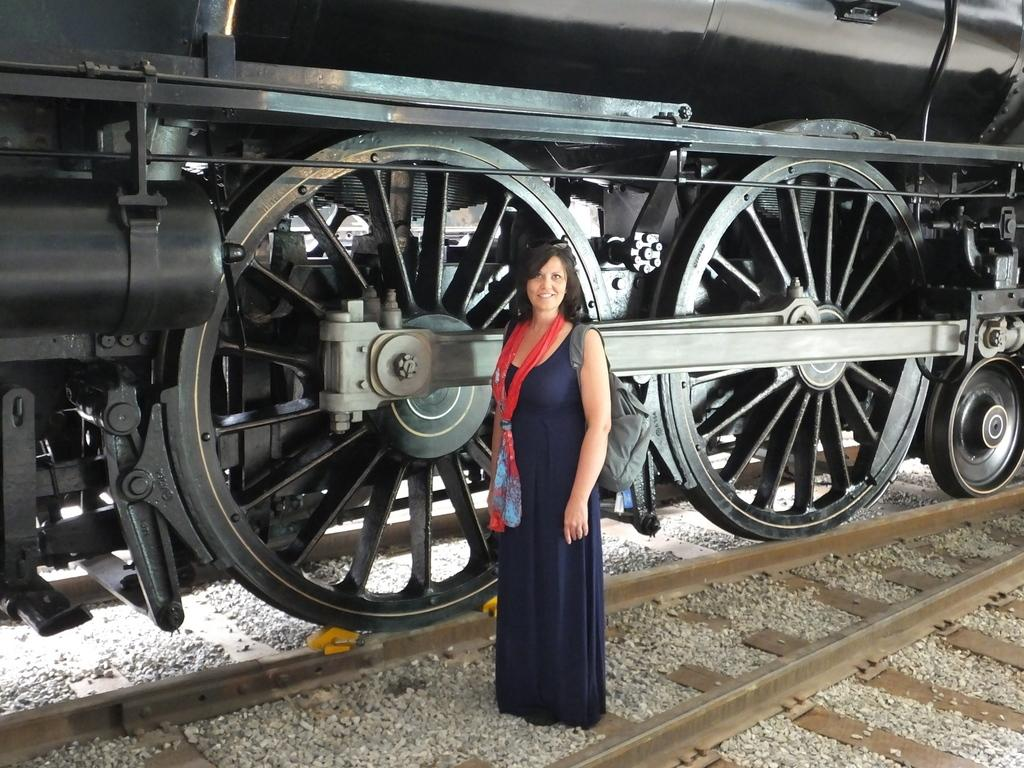What is the main subject of the image? The main subject of the image is a train. Where is the train located in the image? The train is on a railway track in the image. Can you describe the woman in the image? The woman in the image is smiling and wearing a scarf. What can be seen on the ground in the image? There are small stones on the ground in the image. What type of bells can be heard ringing in the image? There are no bells present in the image, and therefore no sound can be heard. 